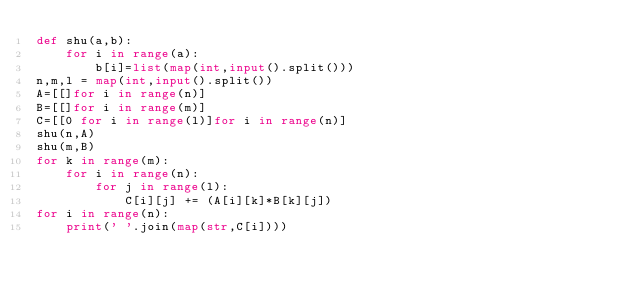<code> <loc_0><loc_0><loc_500><loc_500><_Python_>def shu(a,b):
	for i in range(a):
		b[i]=list(map(int,input().split()))
n,m,l = map(int,input().split())
A=[[]for i in range(n)]
B=[[]for i in range(m)]
C=[[0 for i in range(l)]for i in range(n)]
shu(n,A)
shu(m,B)
for k in range(m):
	for i in range(n):
		for j in range(l):
			C[i][j] += (A[i][k]*B[k][j])
for i in range(n):
	print(' '.join(map(str,C[i])))
</code> 